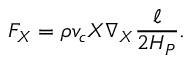<formula> <loc_0><loc_0><loc_500><loc_500>F _ { X } = \rho v _ { c } X \nabla _ { X } { \frac { \ell } { 2 H _ { P } } } .</formula> 